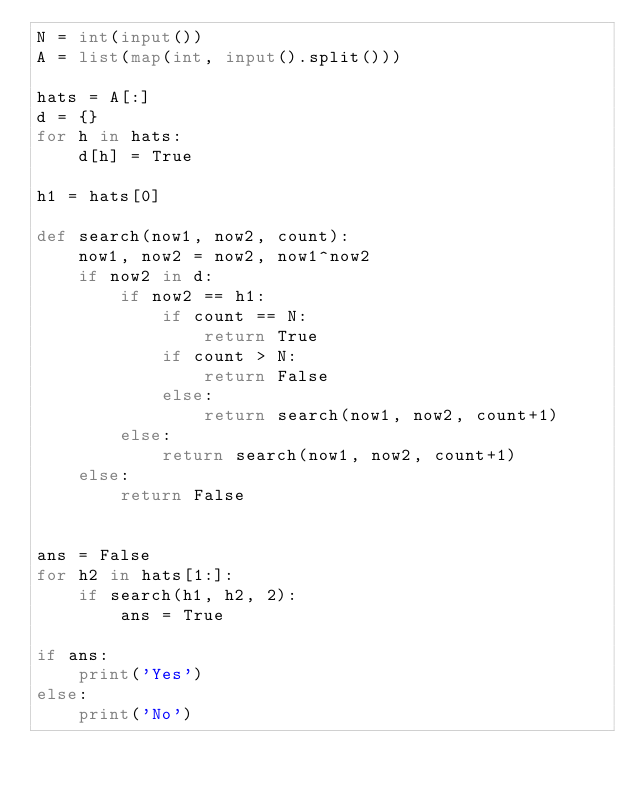Convert code to text. <code><loc_0><loc_0><loc_500><loc_500><_Python_>N = int(input())
A = list(map(int, input().split()))

hats = A[:]
d = {}
for h in hats:
    d[h] = True

h1 = hats[0]
 
def search(now1, now2, count):
    now1, now2 = now2, now1^now2
    if now2 in d:
        if now2 == h1:
            if count == N:
                return True
            if count > N:
                return False
            else:
                return search(now1, now2, count+1)
        else:
            return search(now1, now2, count+1)
    else:
        return False
    

ans = False
for h2 in hats[1:]:
    if search(h1, h2, 2):
        ans = True

if ans:
    print('Yes')
else:
    print('No')</code> 